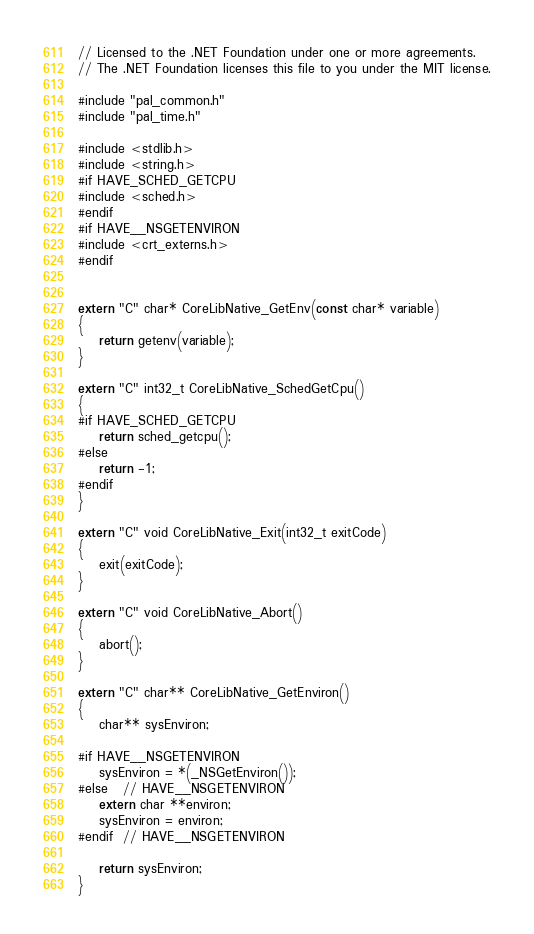<code> <loc_0><loc_0><loc_500><loc_500><_C++_>// Licensed to the .NET Foundation under one or more agreements.
// The .NET Foundation licenses this file to you under the MIT license.

#include "pal_common.h"
#include "pal_time.h"

#include <stdlib.h>
#include <string.h>
#if HAVE_SCHED_GETCPU
#include <sched.h>
#endif
#if HAVE__NSGETENVIRON
#include <crt_externs.h>
#endif


extern "C" char* CoreLibNative_GetEnv(const char* variable)
{
    return getenv(variable);
}

extern "C" int32_t CoreLibNative_SchedGetCpu()
{
#if HAVE_SCHED_GETCPU
    return sched_getcpu();
#else
    return -1;
#endif
}

extern "C" void CoreLibNative_Exit(int32_t exitCode)
{
    exit(exitCode);
}

extern "C" void CoreLibNative_Abort()
{
    abort();
}

extern "C" char** CoreLibNative_GetEnviron()
{
    char** sysEnviron;

#if HAVE__NSGETENVIRON
    sysEnviron = *(_NSGetEnviron());
#else   // HAVE__NSGETENVIRON
    extern char **environ;
    sysEnviron = environ;
#endif  // HAVE__NSGETENVIRON

    return sysEnviron;
}
</code> 